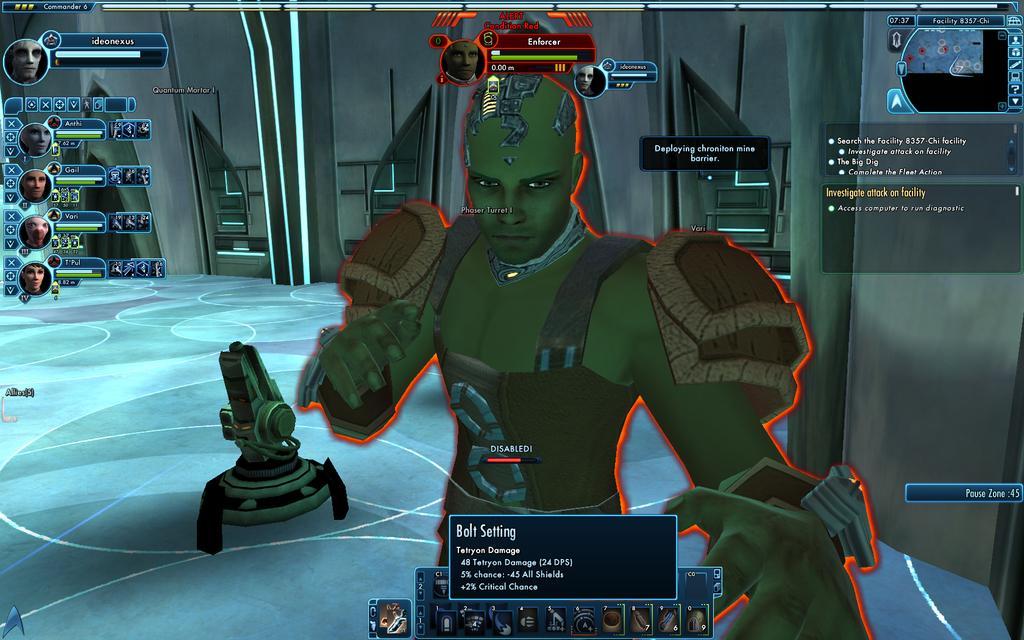In one or two sentences, can you explain what this image depicts? In this image we can see an animated picture of a person. We can also see some text on it. 